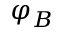Convert formula to latex. <formula><loc_0><loc_0><loc_500><loc_500>\varphi _ { B }</formula> 